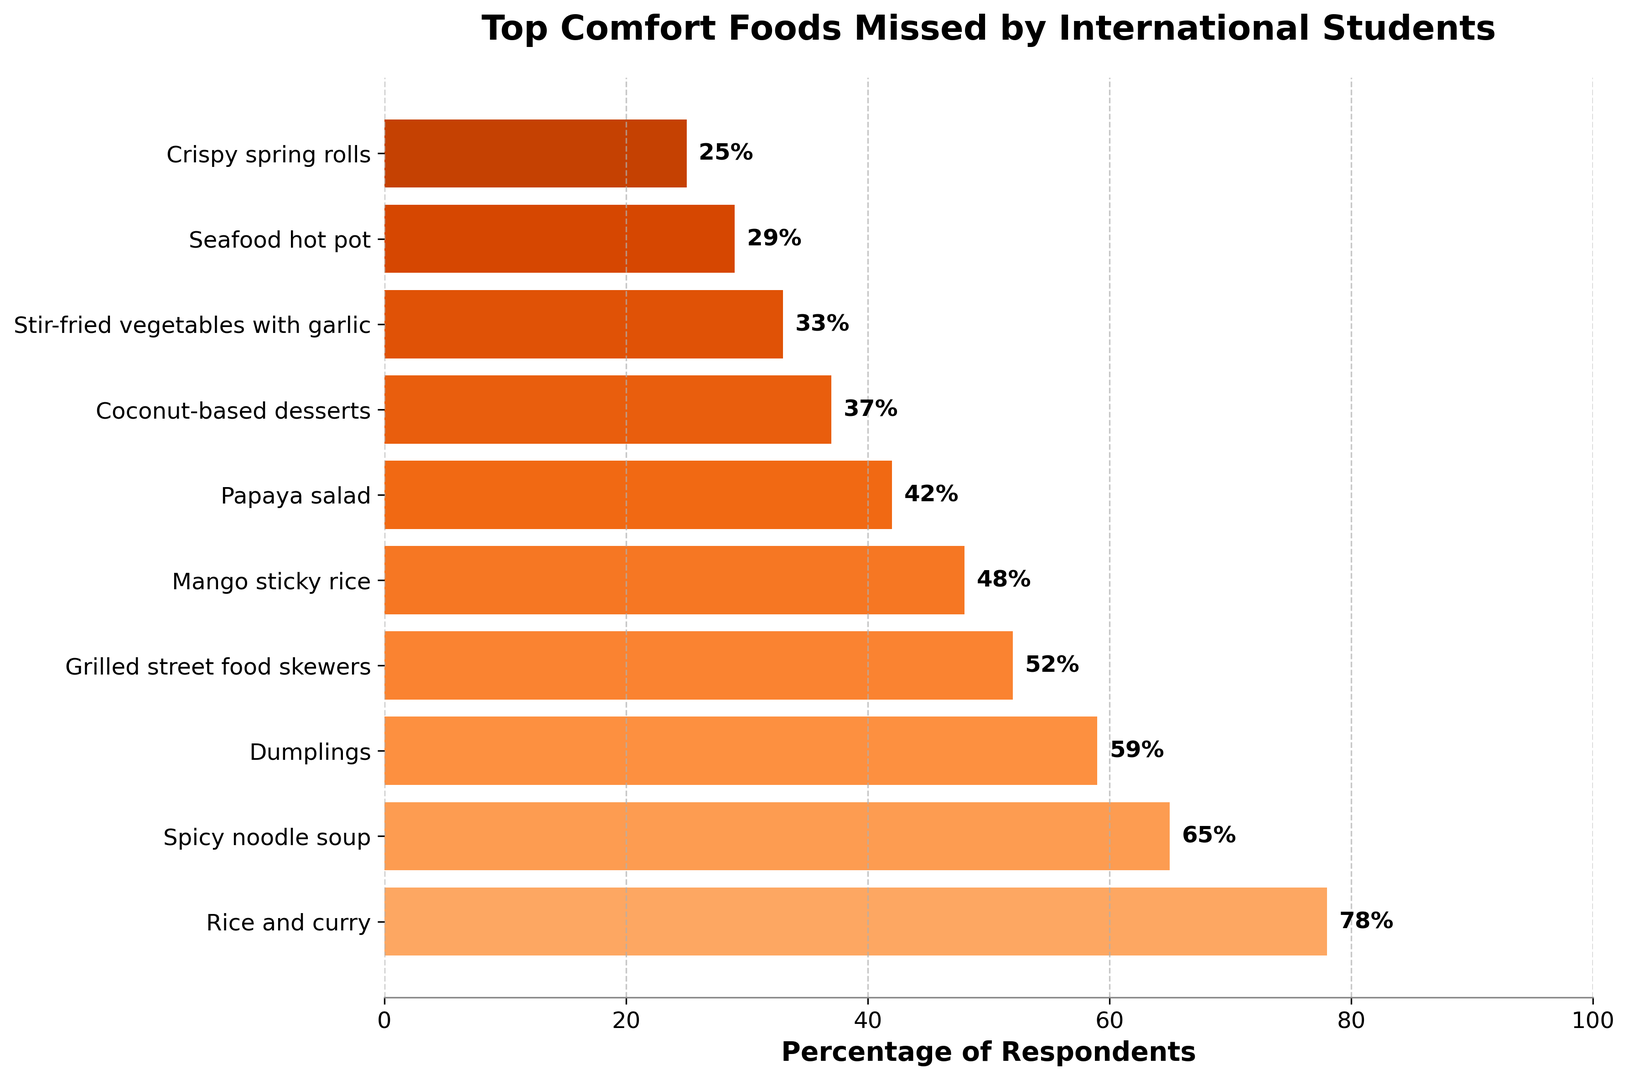Which comfort food is missed by the highest percentage of international students? The bar chart shows the top comfort foods missed by international students with their respective percentages. The food with the highest percentage is the one with the longest bar. Rice and curry has the longest bar, with a percentage of 78%.
Answer: Rice and curry What is the combined percentage of respondents who miss dumplings and grilled street food skewers? To find the combined percentage, add the percentages for dumplings (59%) and grilled street food skewers (52%). 59 + 52 = 111.
Answer: 111 How many foods have a percentage of respondents higher than 50%? By examining the chart, we see that rice and curry (78%), spicy noodle soup (65%), dumplings (59%), and grilled street food skewers (52%) all exceed 50%. This gives us 4 foods.
Answer: 4 Which food is missed by fewer respondents: mango sticky rice or papaya salad? By comparing the lengths of the bars, we see the percentage for mango sticky rice is 48%, and for papaya salad, it is 42%. Papaya salad has a shorter bar, indicating fewer respondents miss it.
Answer: Papaya salad What is the difference in the percentage of respondents who miss spicy noodle soup and crispy spring rolls? Subtract the percentage for crispy spring rolls (25%) from the percentage for spicy noodle soup (65%). 65 - 25 = 40.
Answer: 40 List all comfort foods missed by less than 40% of respondents. By examining the chart, we can identify the foods with percentages less than 40%: papaya salad (42%), coconut-based desserts (37%), stir-fried vegetables with garlic (33%), seafood hot pot (29%), and crispy spring rolls (25%).
Answer: Coconut-based desserts, stir-fried vegetables with garlic, seafood hot pot, crispy spring rolls Which is missed more, seafood hot pot or stir-fried vegetables with garlic? Comparing the bars, the percentage for stir-fried vegetables with garlic is 33%, while for seafood hot pot, it is 29%. Stir-fried vegetables with garlic has a longer bar and thus is missed more.
Answer: Stir-fried vegetables with garlic 